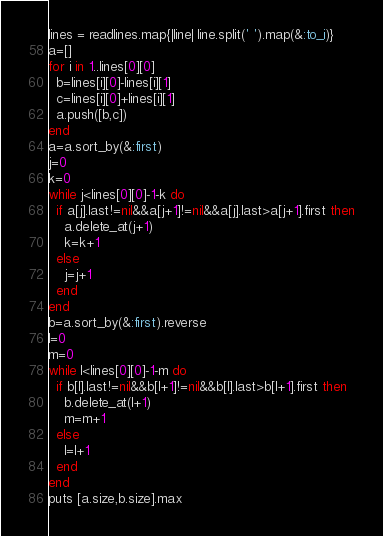Convert code to text. <code><loc_0><loc_0><loc_500><loc_500><_Ruby_>lines = readlines.map{|line| line.split(' ').map(&:to_i)}
a=[]
for i in 1..lines[0][0]
  b=lines[i][0]-lines[i][1]
  c=lines[i][0]+lines[i][1]
  a.push([b,c])
end
a=a.sort_by(&:first)
j=0
k=0
while j<lines[0][0]-1-k do
  if a[j].last!=nil&&a[j+1]!=nil&&a[j].last>a[j+1].first then
    a.delete_at(j+1)
    k=k+1
  else
    j=j+1
  end
end
b=a.sort_by(&:first).reverse
l=0
m=0
while l<lines[0][0]-1-m do
  if b[l].last!=nil&&b[l+1]!=nil&&b[l].last>b[l+1].first then
    b.delete_at(l+1)
    m=m+1
  else
    l=l+1
  end
end
puts [a.size,b.size].max</code> 